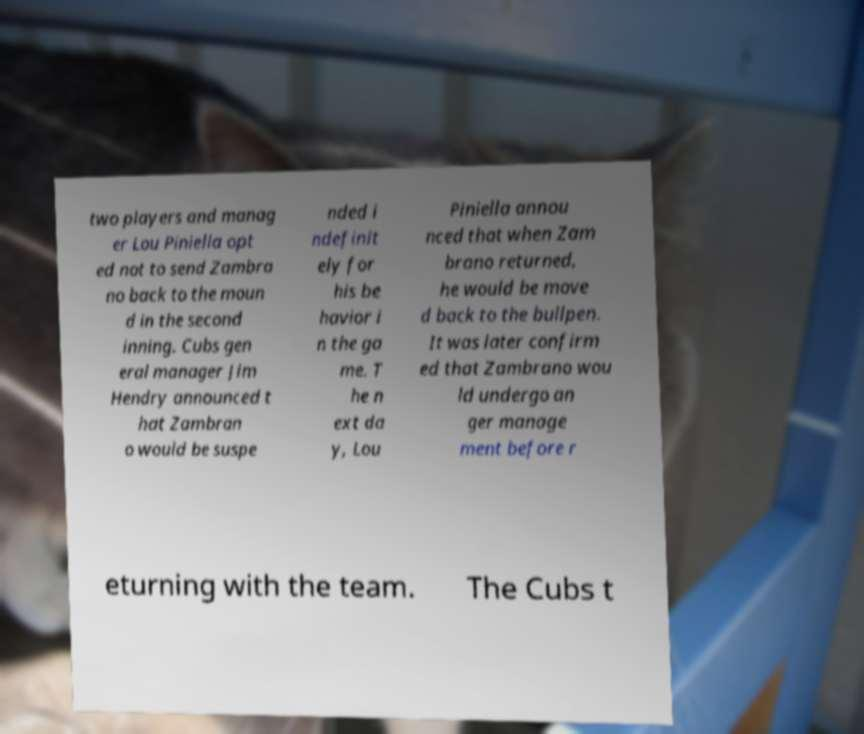What messages or text are displayed in this image? I need them in a readable, typed format. two players and manag er Lou Piniella opt ed not to send Zambra no back to the moun d in the second inning. Cubs gen eral manager Jim Hendry announced t hat Zambran o would be suspe nded i ndefinit ely for his be havior i n the ga me. T he n ext da y, Lou Piniella annou nced that when Zam brano returned, he would be move d back to the bullpen. It was later confirm ed that Zambrano wou ld undergo an ger manage ment before r eturning with the team. The Cubs t 